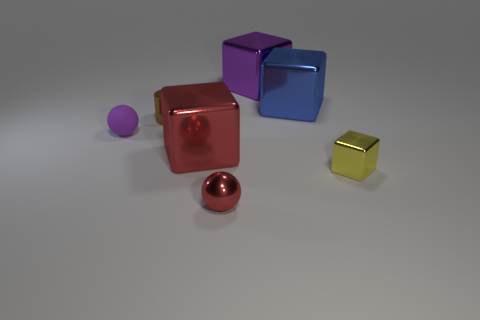What is the shape of the brown metallic thing?
Ensure brevity in your answer.  Cylinder. There is a metallic cube that is the same color as the tiny metal sphere; what size is it?
Ensure brevity in your answer.  Large. What is the size of the red shiny object behind the tiny metallic thing right of the purple metal cube?
Provide a succinct answer. Large. What is the size of the purple thing to the right of the brown shiny thing?
Give a very brief answer. Large. Is the number of purple blocks on the left side of the small purple sphere less than the number of small rubber spheres that are to the left of the big purple thing?
Ensure brevity in your answer.  Yes. The cylinder is what color?
Your response must be concise. Brown. Are there any large metal blocks that have the same color as the shiny ball?
Your answer should be compact. Yes. There is a red metal thing that is right of the big cube that is left of the thing that is behind the big blue object; what shape is it?
Provide a short and direct response. Sphere. What material is the cube behind the large blue thing?
Provide a short and direct response. Metal. There is a sphere that is behind the small sphere that is in front of the metal block left of the purple metal block; what is its size?
Offer a terse response. Small. 